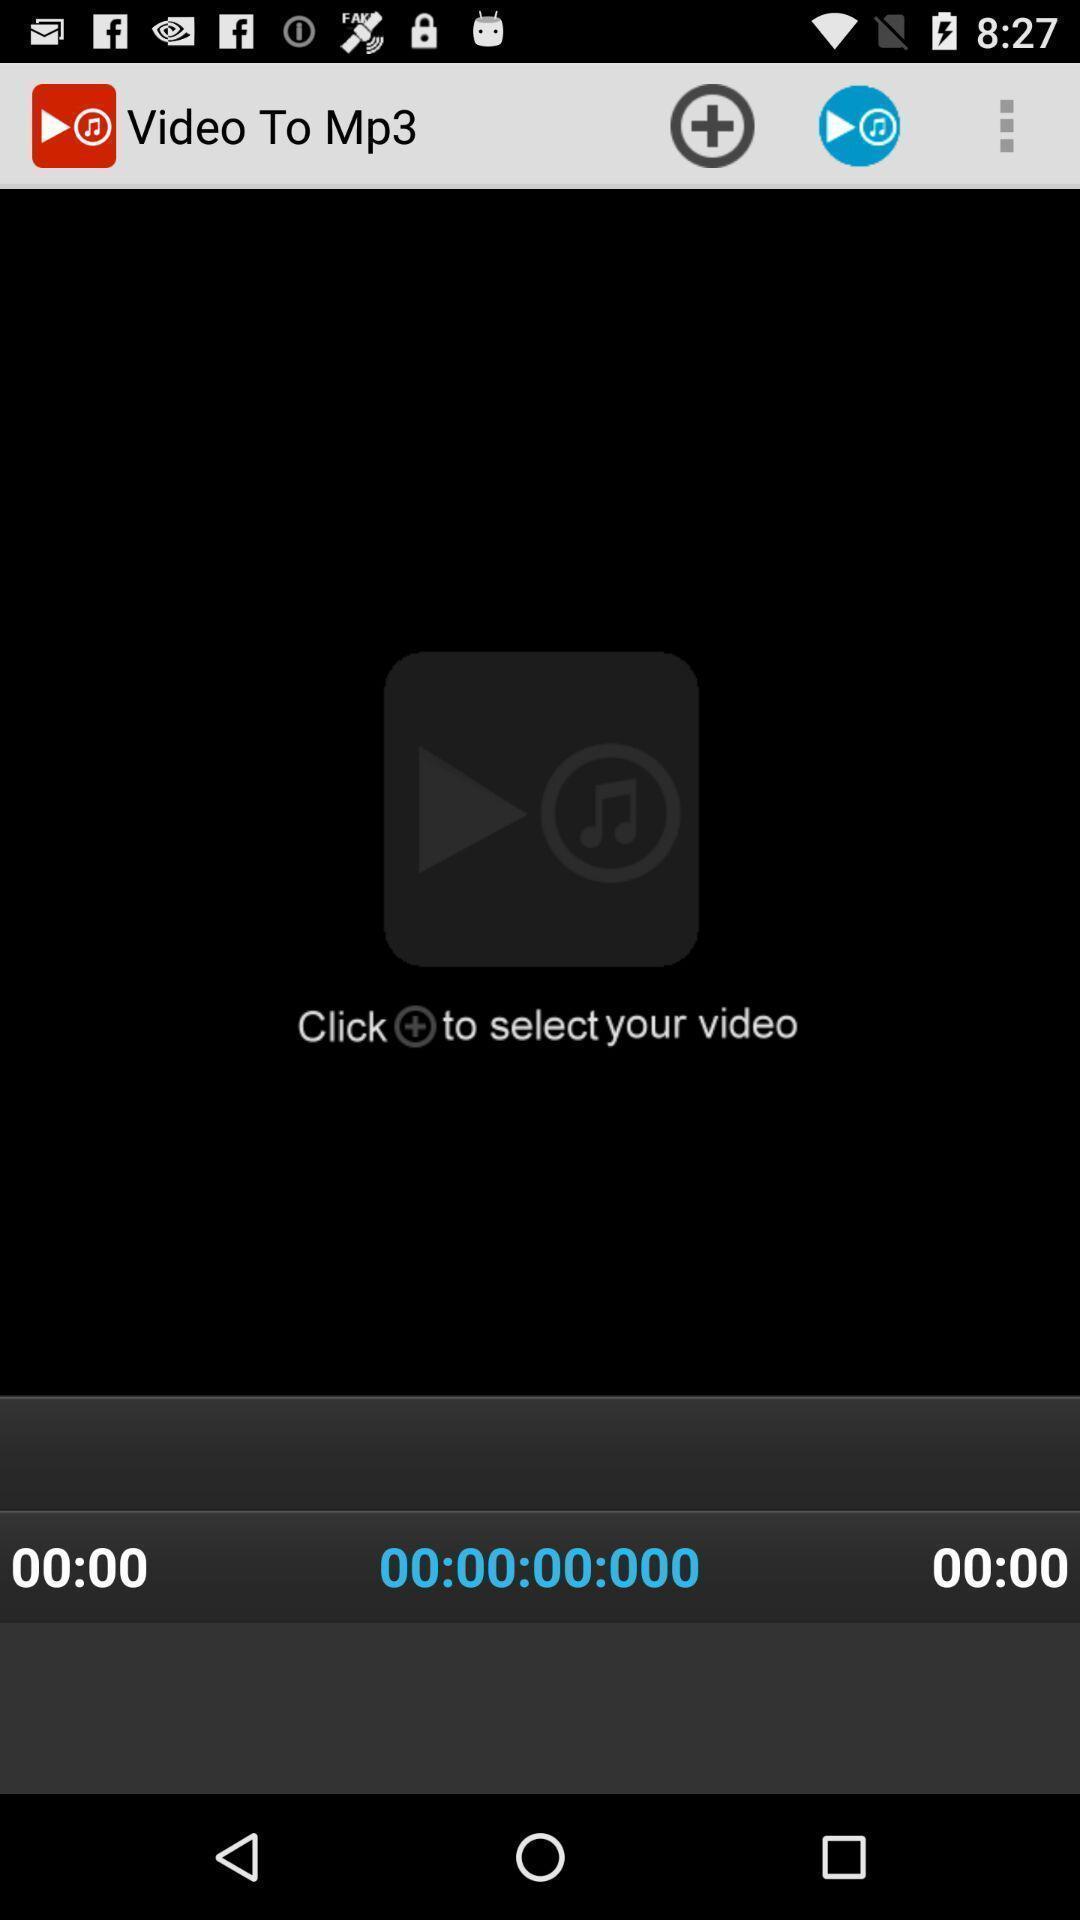Tell me about the visual elements in this screen capture. Screen shows video to mp3. 